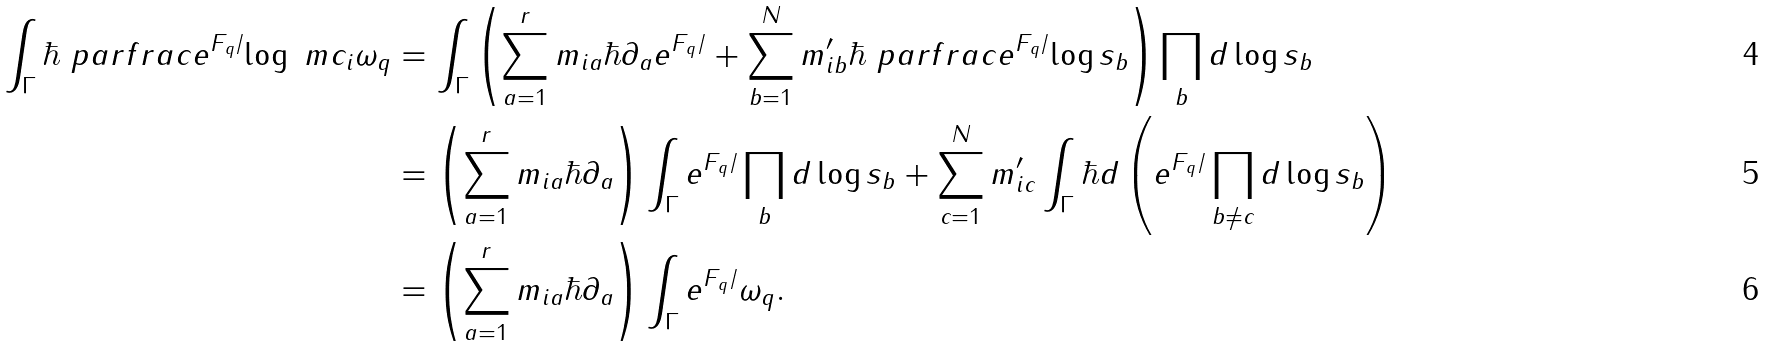Convert formula to latex. <formula><loc_0><loc_0><loc_500><loc_500>\int _ { \Gamma } \hbar { \ } p a r f r a c { e ^ { F _ { q } / } } { \log \ m c _ { i } } \omega _ { q } & = \int _ { \Gamma } \left ( \sum _ { a = 1 } ^ { r } m _ { i a } \hbar { \partial } _ { a } e ^ { F _ { q } / } + \sum _ { b = 1 } ^ { N } m ^ { \prime } _ { i b } \hbar { \ } p a r f r a c { e ^ { F _ { q } / } } { \log s _ { b } } \right ) \prod _ { b } d \log s _ { b } \\ & = \left ( \sum _ { a = 1 } ^ { r } m _ { i a } \hbar { \partial } _ { a } \right ) \int _ { \Gamma } e ^ { F _ { q } / } \prod _ { b } d \log s _ { b } + \sum _ { c = 1 } ^ { N } m ^ { \prime } _ { i c } \int _ { \Gamma } \hbar { d } \left ( { e ^ { F _ { q } / } } \prod _ { b \neq c } d \log s _ { b } \right ) \\ & = \left ( \sum _ { a = 1 } ^ { r } m _ { i a } \hbar { \partial } _ { a } \right ) \int _ { \Gamma } e ^ { F _ { q } / } \omega _ { q } .</formula> 